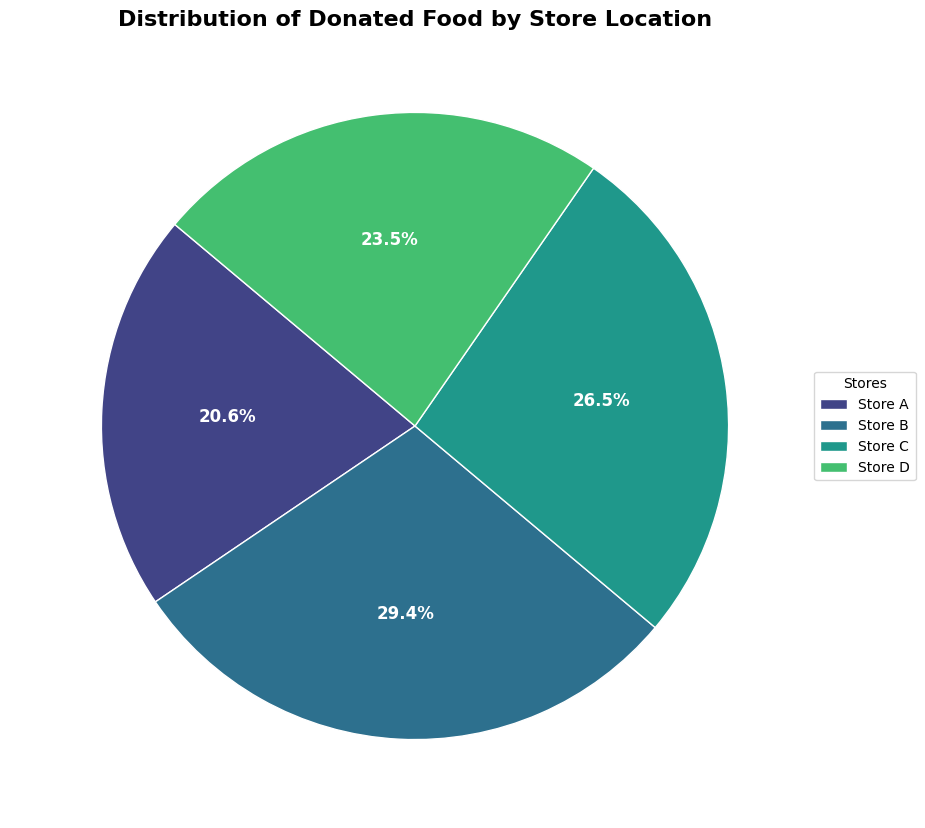what percentage of total donated food does Store B contribute? Store B donates 500 kg of food. The total donation is 350 + 500 + 450 + 400 = 1700 kg. The percentage contribution of Store B is (500 / 1700) * 100 ≈ 29.4%.
Answer: 29.4% Which store donates the least food? By looking at the labeled pie chart, we see that Store A has the smallest percentage contribution. Hence, Store A donates the least food.
Answer: Store A Do Stores C and D together donate more food than Store B? Stores C and D together donate 450 + 400 = 850 kg, and Store B donates 500 kg. Since 850 kg is greater than 500 kg, Stores C and D together donate more food than Store B.
Answer: Yes Which store contributes approximately one-quarter of the total donations? The total donation is 1700 kg. Approximately one-quarter of this would be 1700 / 4 = 425 kg. Looking at the pie chart, Store C contributes 450 kg, which is the closest to 425 kg.
Answer: Store C What is the difference in food donated between the highest contributing store and the lowest contributing store? Store B has the highest donation with 500 kg, and Store A has the lowest with 350 kg. The difference is 500 - 350 = 150 kg.
Answer: 150 kg Which stores contribute more than 25% each to the total donations? From the pie chart, we see that Store B (29.4%) and Store C (26.5%) both contribute more than 25% each to the total donations.
Answer: Store B and Store C If Store D increases its donation by 100 kg, will it surpass Store C in total donated food? Currently, Store D donates 400 kg, and Store C donates 450 kg. If Store D increases its donation by 100 kg, its total will be 400 + 100 = 500 kg, which is greater than 450 kg.
Answer: Yes What is the average amount of food donated per store? The total donation is 1700 kg, and there are 4 stores. The average donation per store is 1700 / 4 = 425 kg.
Answer: 425 kg 